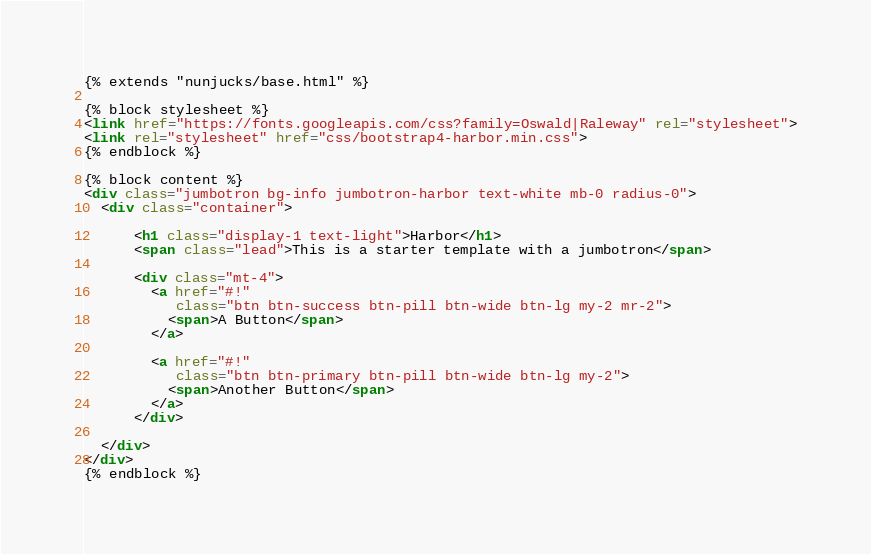<code> <loc_0><loc_0><loc_500><loc_500><_HTML_>{% extends "nunjucks/base.html" %}

{% block stylesheet %}
<link href="https://fonts.googleapis.com/css?family=Oswald|Raleway" rel="stylesheet">
<link rel="stylesheet" href="css/bootstrap4-harbor.min.css">
{% endblock %}

{% block content %}
<div class="jumbotron bg-info jumbotron-harbor text-white mb-0 radius-0">
  <div class="container">

      <h1 class="display-1 text-light">Harbor</h1>
      <span class="lead">This is a starter template with a jumbotron</span>

      <div class="mt-4">
        <a href="#!"
           class="btn btn-success btn-pill btn-wide btn-lg my-2 mr-2">
          <span>A Button</span>
        </a>

        <a href="#!"
           class="btn btn-primary btn-pill btn-wide btn-lg my-2">
          <span>Another Button</span>
        </a>
      </div>

  </div>
</div>
{% endblock %}

</code> 